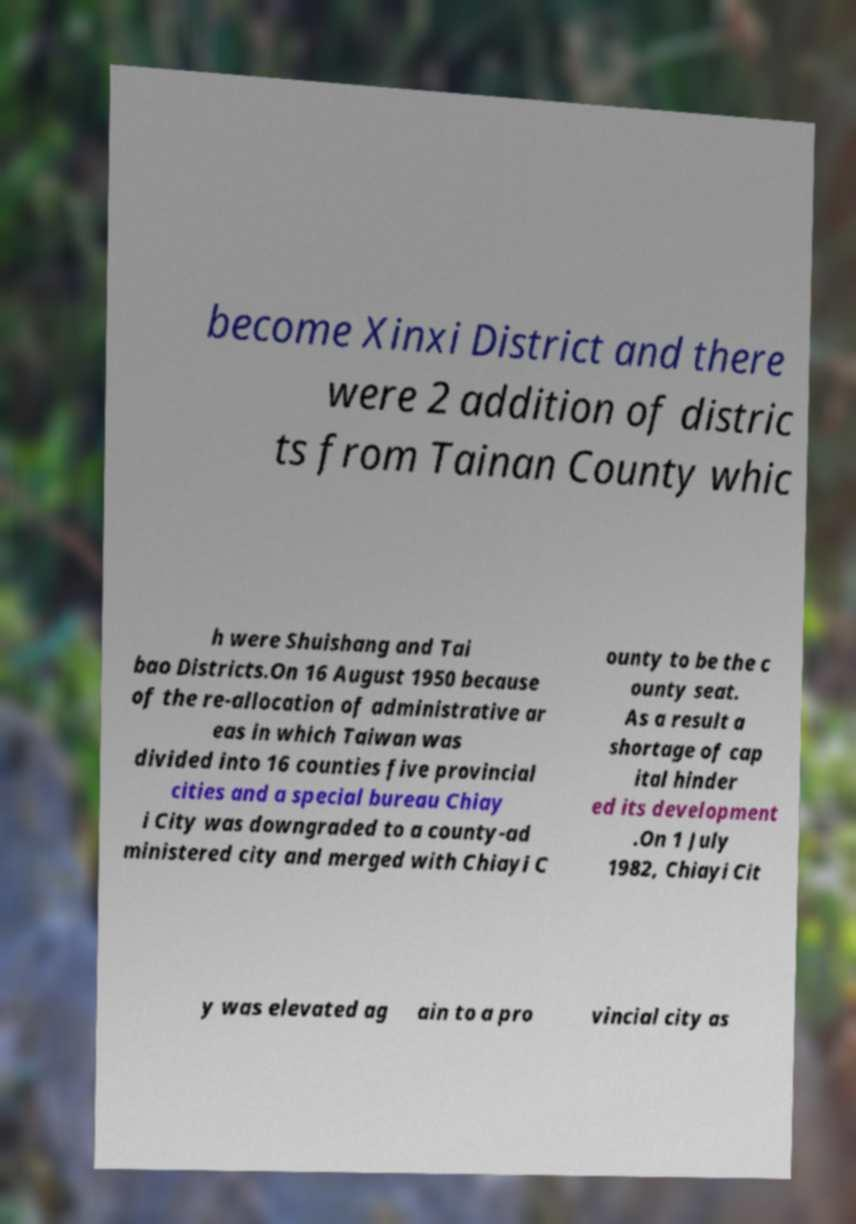Could you assist in decoding the text presented in this image and type it out clearly? become Xinxi District and there were 2 addition of distric ts from Tainan County whic h were Shuishang and Tai bao Districts.On 16 August 1950 because of the re-allocation of administrative ar eas in which Taiwan was divided into 16 counties five provincial cities and a special bureau Chiay i City was downgraded to a county-ad ministered city and merged with Chiayi C ounty to be the c ounty seat. As a result a shortage of cap ital hinder ed its development .On 1 July 1982, Chiayi Cit y was elevated ag ain to a pro vincial city as 